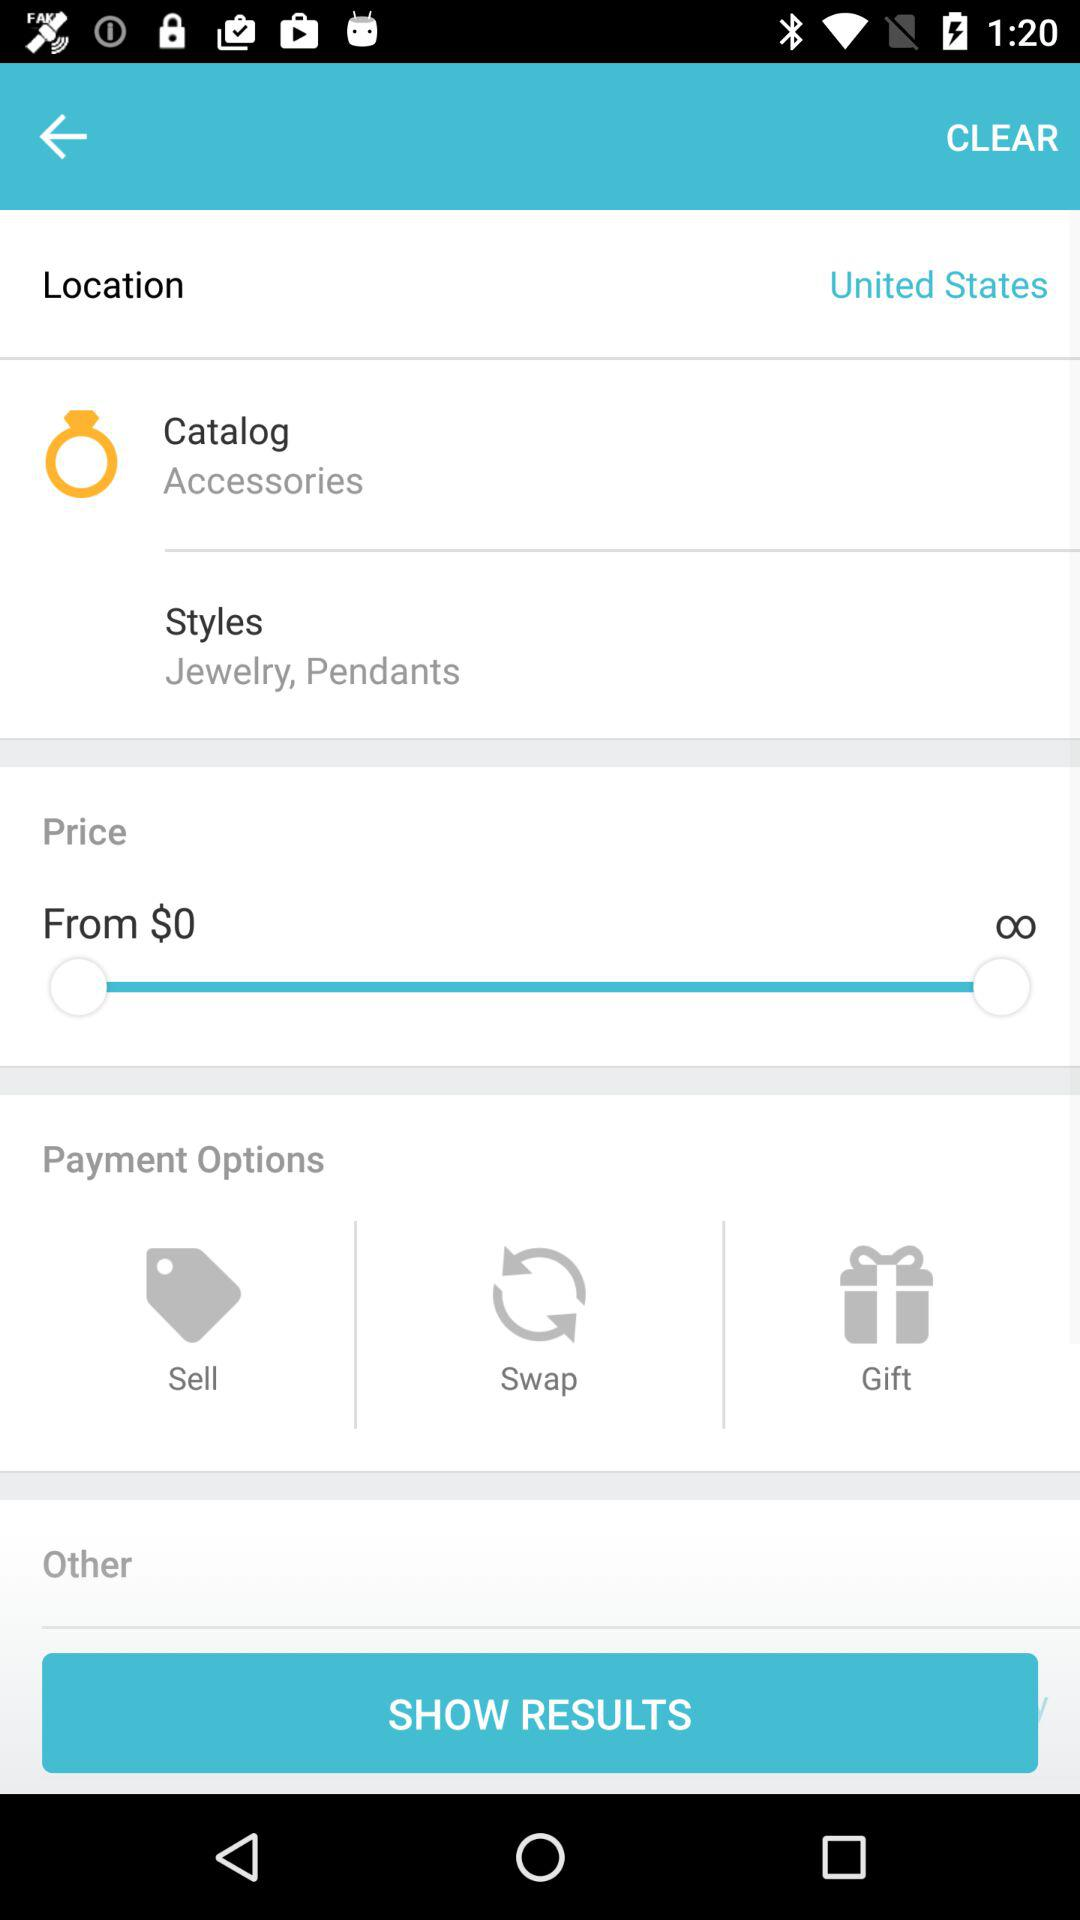What are the available payment options? The available options are "Sell", "Swap" and "Gift". 